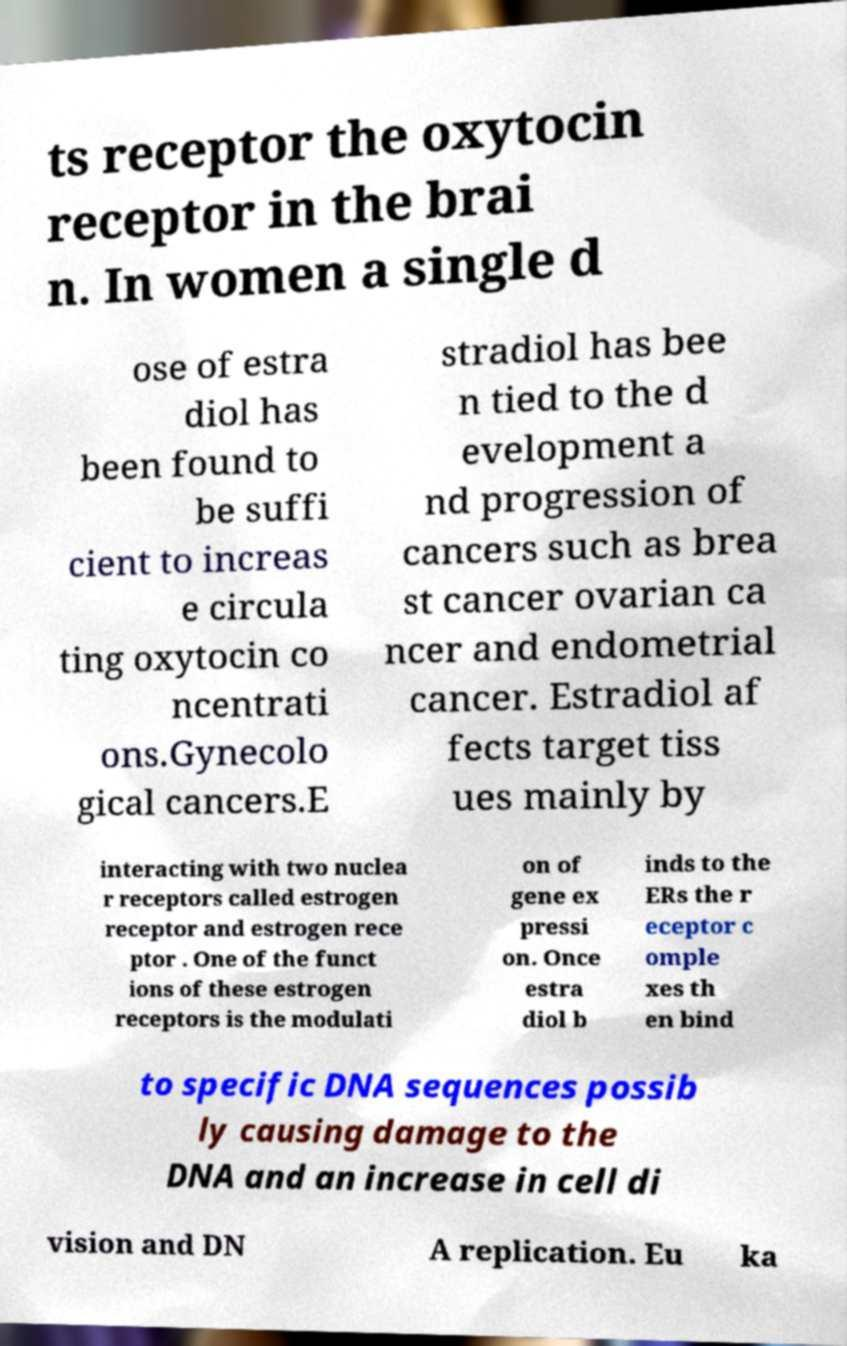Can you accurately transcribe the text from the provided image for me? ts receptor the oxytocin receptor in the brai n. In women a single d ose of estra diol has been found to be suffi cient to increas e circula ting oxytocin co ncentrati ons.Gynecolo gical cancers.E stradiol has bee n tied to the d evelopment a nd progression of cancers such as brea st cancer ovarian ca ncer and endometrial cancer. Estradiol af fects target tiss ues mainly by interacting with two nuclea r receptors called estrogen receptor and estrogen rece ptor . One of the funct ions of these estrogen receptors is the modulati on of gene ex pressi on. Once estra diol b inds to the ERs the r eceptor c omple xes th en bind to specific DNA sequences possib ly causing damage to the DNA and an increase in cell di vision and DN A replication. Eu ka 